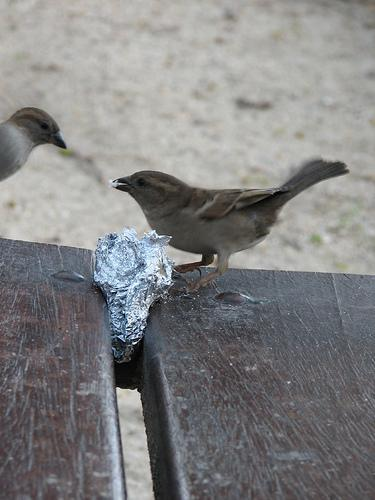What is tinfoil made of? aluminum 